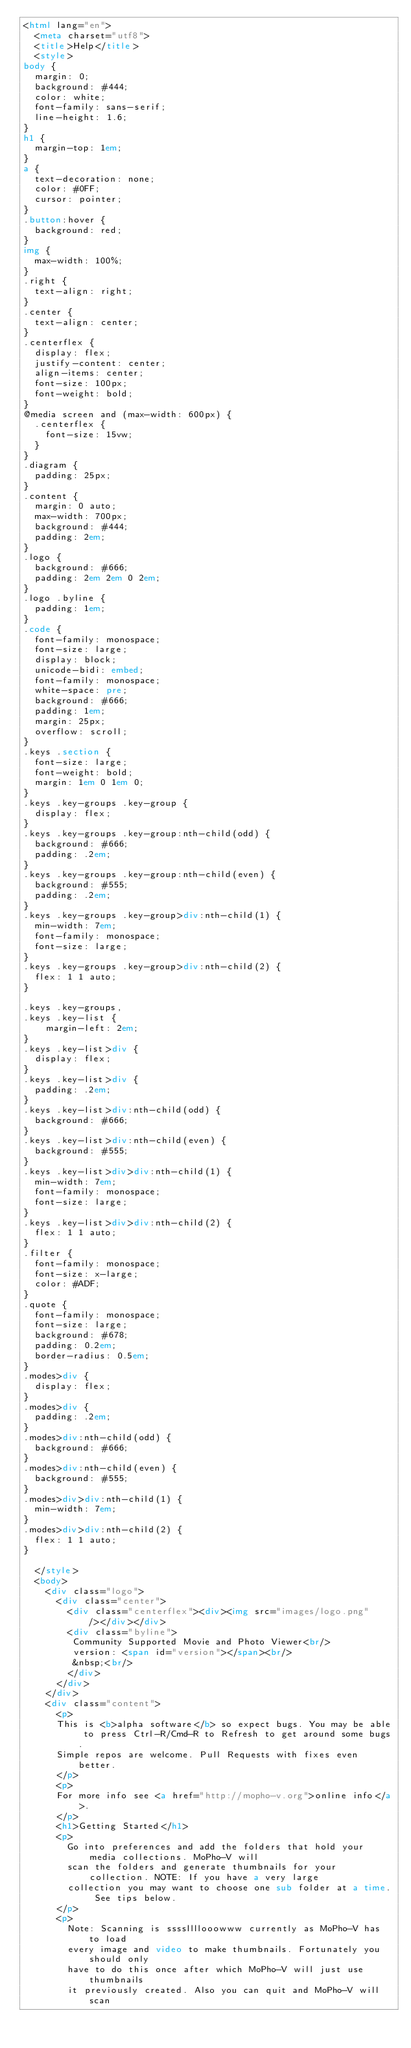Convert code to text. <code><loc_0><loc_0><loc_500><loc_500><_HTML_><html lang="en">
  <meta charset="utf8">
  <title>Help</title>
  <style>
body {
  margin: 0;
  background: #444;
  color: white;
  font-family: sans-serif;
  line-height: 1.6;
}
h1 {
  margin-top: 1em;
}
a {
  text-decoration: none;
  color: #0FF;
  cursor: pointer;
}
.button:hover {
  background: red;
}
img {
  max-width: 100%;
}
.right {
  text-align: right;
}
.center {
  text-align: center;
}
.centerflex {
  display: flex;
  justify-content: center;
  align-items: center;
  font-size: 100px;
  font-weight: bold;
}
@media screen and (max-width: 600px) {
  .centerflex {
    font-size: 15vw;
  }
}
.diagram {
  padding: 25px;
}
.content {
  margin: 0 auto;
  max-width: 700px;
  background: #444;
  padding: 2em;
}
.logo {
  background: #666;
  padding: 2em 2em 0 2em;
}
.logo .byline {
  padding: 1em;
}
.code {
  font-family: monospace;
  font-size: large;
  display: block;
  unicode-bidi: embed;
  font-family: monospace;
  white-space: pre;  
  background: #666;
  padding: 1em;
  margin: 25px;
  overflow: scroll;
}
.keys .section {
  font-size: large;
  font-weight: bold;
  margin: 1em 0 1em 0;
}
.keys .key-groups .key-group {
  display: flex;
}
.keys .key-groups .key-group:nth-child(odd) {
  background: #666;
  padding: .2em;
}
.keys .key-groups .key-group:nth-child(even) {
  background: #555;
  padding: .2em;
}
.keys .key-groups .key-group>div:nth-child(1) {
  min-width: 7em;
  font-family: monospace;
  font-size: large;
}
.keys .key-groups .key-group>div:nth-child(2) {
  flex: 1 1 auto;
}

.keys .key-groups,
.keys .key-list {
    margin-left: 2em;
}
.keys .key-list>div {
  display: flex;
}
.keys .key-list>div {
  padding: .2em;
}
.keys .key-list>div:nth-child(odd) {
  background: #666;
}
.keys .key-list>div:nth-child(even) {
  background: #555;
}
.keys .key-list>div>div:nth-child(1) {
  min-width: 7em;
  font-family: monospace;
  font-size: large;
}
.keys .key-list>div>div:nth-child(2) {
  flex: 1 1 auto;
}
.filter {
  font-family: monospace;  
  font-size: x-large;
  color: #ADF;
}
.quote {
  font-family: monospace;
  font-size: large;
  background: #678;
  padding: 0.2em;
  border-radius: 0.5em;
}
.modes>div {
  display: flex;
}
.modes>div {
  padding: .2em;
}
.modes>div:nth-child(odd) {
  background: #666;
}
.modes>div:nth-child(even) {
  background: #555;
}
.modes>div>div:nth-child(1) {
  min-width: 7em;
}
.modes>div>div:nth-child(2) {
  flex: 1 1 auto;  
}
    
  </style>
  <body>
    <div class="logo">
      <div class="center">
        <div class="centerflex"><div><img src="images/logo.png" /></div></div>
        <div class="byline">
         Community Supported Movie and Photo Viewer<br/>
         version: <span id="version"></span><br/>
         &nbsp;<br/>
        </div>
      </div>
    </div>
    <div class="content">
      <p>
      This is <b>alpha software</b> so expect bugs. You may be able to press Ctrl-R/Cmd-R to Refresh to get around some bugs.
      Simple repos are welcome. Pull Requests with fixes even better.
      </p>
      <p>
      For more info see <a href="http://mopho-v.org">online info</a>.
      </p>
      <h1>Getting Started</h1>
      <p>
        Go into preferences and add the folders that hold your media collections. MoPho-V will
        scan the folders and generate thumbnails for your collection. NOTE: If you have a very large
        collection you may want to choose one sub folder at a time. See tips below.
      </p>
      <p>
        Note: Scanning is ssssllllooowww currently as MoPho-V has to load
        every image and video to make thumbnails. Fortunately you should only
        have to do this once after which MoPho-V will just use thumbnails
        it previously created. Also you can quit and MoPho-V will scan</code> 